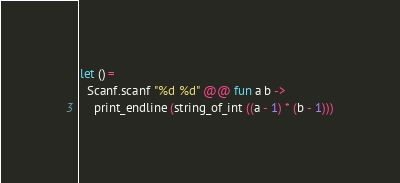<code> <loc_0><loc_0><loc_500><loc_500><_OCaml_>let () =
  Scanf.scanf "%d %d" @@ fun a b ->
    print_endline (string_of_int ((a - 1) * (b - 1)))</code> 